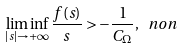<formula> <loc_0><loc_0><loc_500><loc_500>\liminf _ { | s | \rightarrow + \infty } \frac { f ( s ) } { s } > - \frac { 1 } { C _ { \Omega } } , \ n o n</formula> 